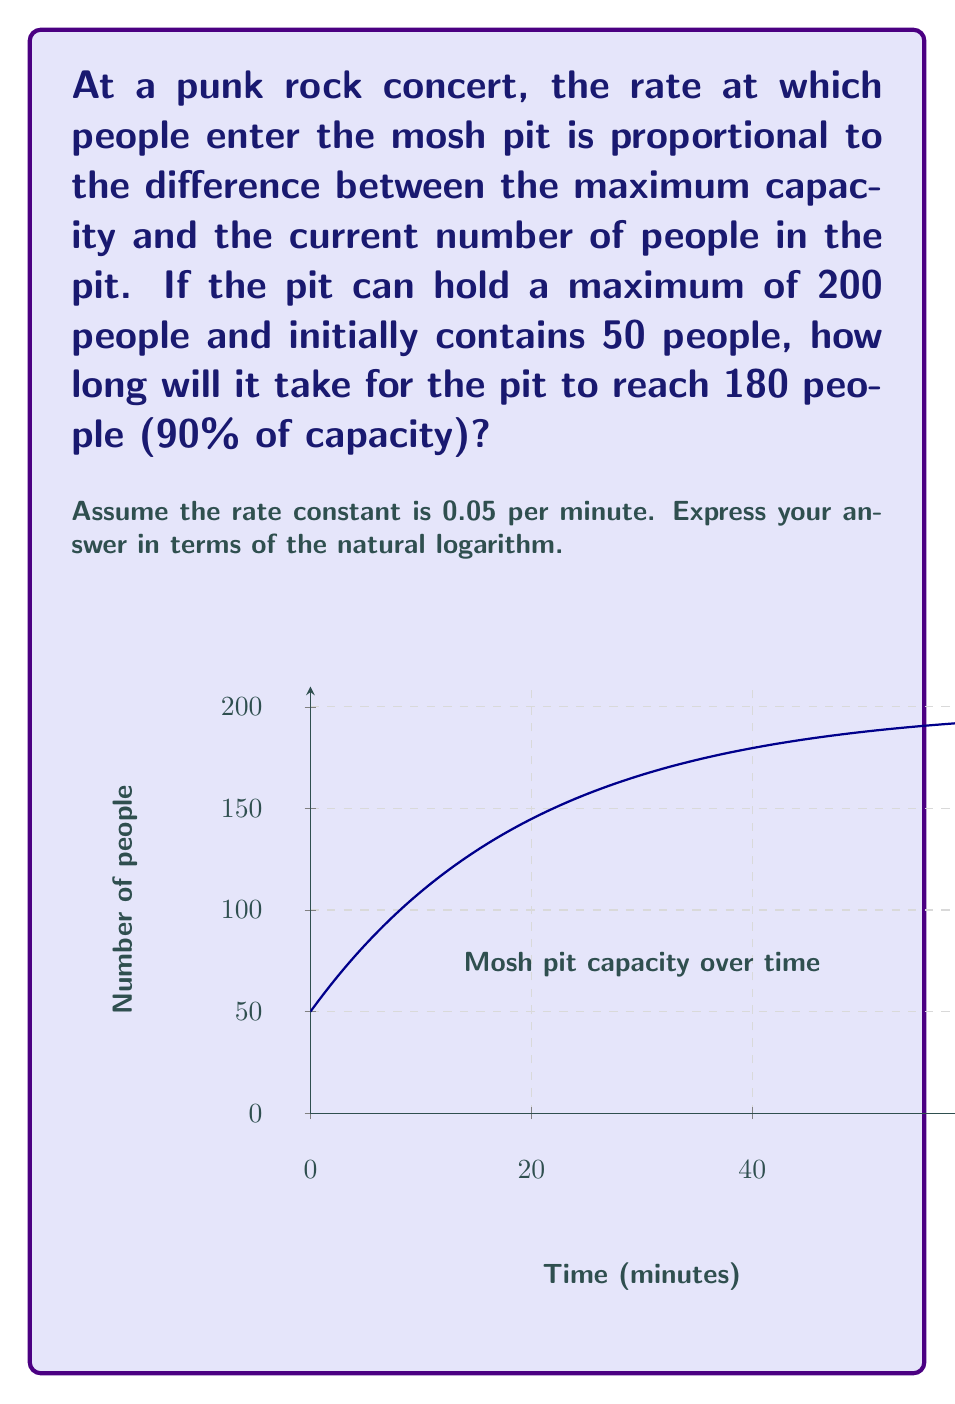Teach me how to tackle this problem. Let's approach this step-by-step using a first-order differential equation:

1) Let $N(t)$ be the number of people in the pit at time $t$.

2) The rate of change is proportional to $(200 - N)$:

   $$\frac{dN}{dt} = k(200 - N)$$

   where $k = 0.05$ is the rate constant.

3) This is a separable differential equation. Rearranging:

   $$\frac{dN}{200 - N} = k dt$$

4) Integrating both sides:

   $$-\ln|200 - N| = kt + C$$

5) Using the initial condition $N(0) = 50$:

   $$-\ln|200 - 50| = 0 + C$$
   $$C = -\ln(150)$$

6) Substituting back:

   $$-\ln|200 - N| = kt - \ln(150)$$

7) Solving for $N$:

   $$N = 200 - 150e^{-kt}$$

8) We want to find $t$ when $N = 180$:

   $$180 = 200 - 150e^{-0.05t}$$

9) Solving for $t$:

   $$150e^{-0.05t} = 20$$
   $$e^{-0.05t} = \frac{2}{15}$$
   $$-0.05t = \ln(\frac{2}{15})$$
   $$t = -\frac{1}{0.05}\ln(\frac{2}{15}) = 20\ln(\frac{15}{2})$$
Answer: $20\ln(\frac{15}{2})$ minutes 